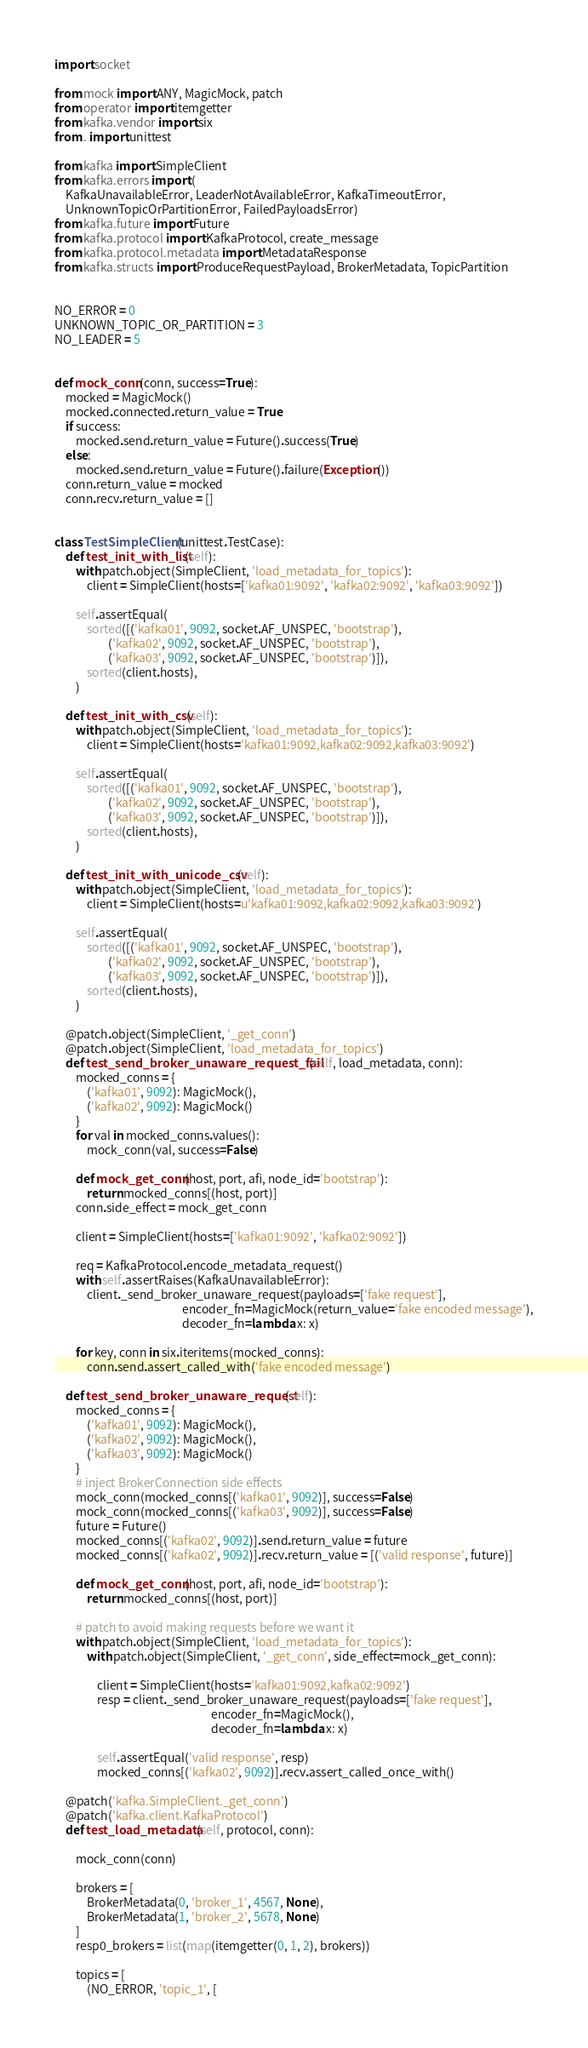<code> <loc_0><loc_0><loc_500><loc_500><_Python_>import socket

from mock import ANY, MagicMock, patch
from operator import itemgetter
from kafka.vendor import six
from . import unittest

from kafka import SimpleClient
from kafka.errors import (
    KafkaUnavailableError, LeaderNotAvailableError, KafkaTimeoutError,
    UnknownTopicOrPartitionError, FailedPayloadsError)
from kafka.future import Future
from kafka.protocol import KafkaProtocol, create_message
from kafka.protocol.metadata import MetadataResponse
from kafka.structs import ProduceRequestPayload, BrokerMetadata, TopicPartition


NO_ERROR = 0
UNKNOWN_TOPIC_OR_PARTITION = 3
NO_LEADER = 5


def mock_conn(conn, success=True):
    mocked = MagicMock()
    mocked.connected.return_value = True
    if success:
        mocked.send.return_value = Future().success(True)
    else:
        mocked.send.return_value = Future().failure(Exception())
    conn.return_value = mocked
    conn.recv.return_value = []


class TestSimpleClient(unittest.TestCase):
    def test_init_with_list(self):
        with patch.object(SimpleClient, 'load_metadata_for_topics'):
            client = SimpleClient(hosts=['kafka01:9092', 'kafka02:9092', 'kafka03:9092'])

        self.assertEqual(
            sorted([('kafka01', 9092, socket.AF_UNSPEC, 'bootstrap'),
                    ('kafka02', 9092, socket.AF_UNSPEC, 'bootstrap'),
                    ('kafka03', 9092, socket.AF_UNSPEC, 'bootstrap')]),
            sorted(client.hosts),
        )

    def test_init_with_csv(self):
        with patch.object(SimpleClient, 'load_metadata_for_topics'):
            client = SimpleClient(hosts='kafka01:9092,kafka02:9092,kafka03:9092')

        self.assertEqual(
            sorted([('kafka01', 9092, socket.AF_UNSPEC, 'bootstrap'),
                    ('kafka02', 9092, socket.AF_UNSPEC, 'bootstrap'),
                    ('kafka03', 9092, socket.AF_UNSPEC, 'bootstrap')]),
            sorted(client.hosts),
        )

    def test_init_with_unicode_csv(self):
        with patch.object(SimpleClient, 'load_metadata_for_topics'):
            client = SimpleClient(hosts=u'kafka01:9092,kafka02:9092,kafka03:9092')

        self.assertEqual(
            sorted([('kafka01', 9092, socket.AF_UNSPEC, 'bootstrap'),
                    ('kafka02', 9092, socket.AF_UNSPEC, 'bootstrap'),
                    ('kafka03', 9092, socket.AF_UNSPEC, 'bootstrap')]),
            sorted(client.hosts),
        )

    @patch.object(SimpleClient, '_get_conn')
    @patch.object(SimpleClient, 'load_metadata_for_topics')
    def test_send_broker_unaware_request_fail(self, load_metadata, conn):
        mocked_conns = {
            ('kafka01', 9092): MagicMock(),
            ('kafka02', 9092): MagicMock()
        }
        for val in mocked_conns.values():
            mock_conn(val, success=False)

        def mock_get_conn(host, port, afi, node_id='bootstrap'):
            return mocked_conns[(host, port)]
        conn.side_effect = mock_get_conn

        client = SimpleClient(hosts=['kafka01:9092', 'kafka02:9092'])

        req = KafkaProtocol.encode_metadata_request()
        with self.assertRaises(KafkaUnavailableError):
            client._send_broker_unaware_request(payloads=['fake request'],
                                                encoder_fn=MagicMock(return_value='fake encoded message'),
                                                decoder_fn=lambda x: x)

        for key, conn in six.iteritems(mocked_conns):
            conn.send.assert_called_with('fake encoded message')

    def test_send_broker_unaware_request(self):
        mocked_conns = {
            ('kafka01', 9092): MagicMock(),
            ('kafka02', 9092): MagicMock(),
            ('kafka03', 9092): MagicMock()
        }
        # inject BrokerConnection side effects
        mock_conn(mocked_conns[('kafka01', 9092)], success=False)
        mock_conn(mocked_conns[('kafka03', 9092)], success=False)
        future = Future()
        mocked_conns[('kafka02', 9092)].send.return_value = future
        mocked_conns[('kafka02', 9092)].recv.return_value = [('valid response', future)]

        def mock_get_conn(host, port, afi, node_id='bootstrap'):
            return mocked_conns[(host, port)]

        # patch to avoid making requests before we want it
        with patch.object(SimpleClient, 'load_metadata_for_topics'):
            with patch.object(SimpleClient, '_get_conn', side_effect=mock_get_conn):

                client = SimpleClient(hosts='kafka01:9092,kafka02:9092')
                resp = client._send_broker_unaware_request(payloads=['fake request'],
                                                           encoder_fn=MagicMock(),
                                                           decoder_fn=lambda x: x)

                self.assertEqual('valid response', resp)
                mocked_conns[('kafka02', 9092)].recv.assert_called_once_with()

    @patch('kafka.SimpleClient._get_conn')
    @patch('kafka.client.KafkaProtocol')
    def test_load_metadata(self, protocol, conn):

        mock_conn(conn)

        brokers = [
            BrokerMetadata(0, 'broker_1', 4567, None),
            BrokerMetadata(1, 'broker_2', 5678, None)
        ]
        resp0_brokers = list(map(itemgetter(0, 1, 2), brokers))

        topics = [
            (NO_ERROR, 'topic_1', [</code> 